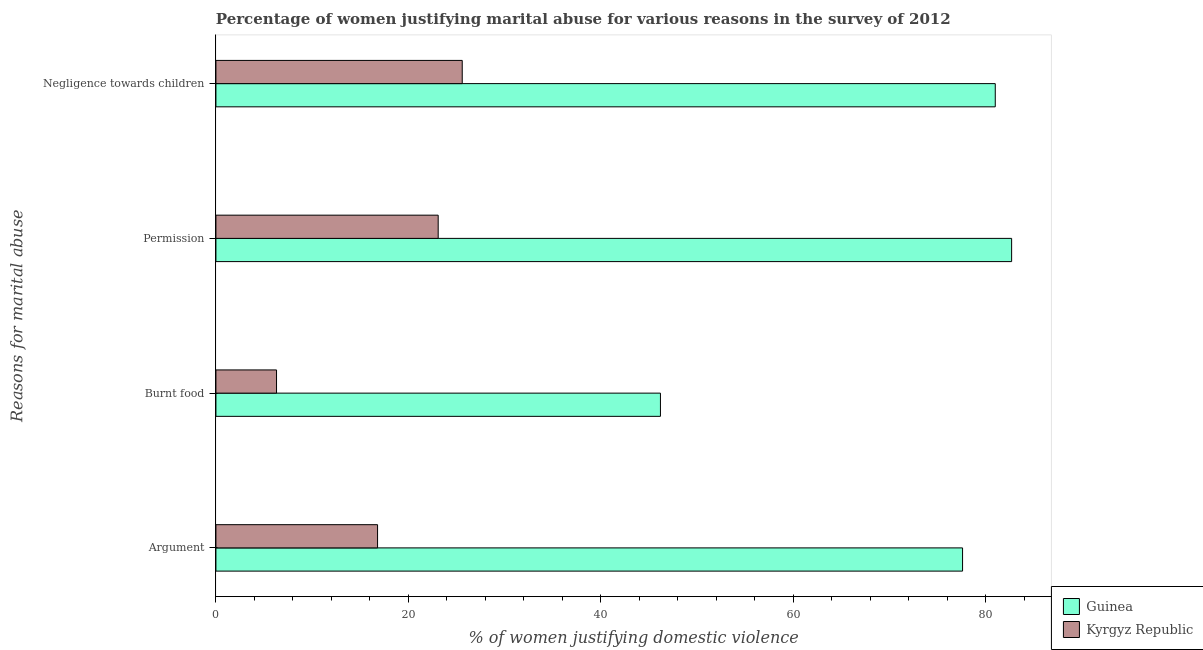Are the number of bars per tick equal to the number of legend labels?
Give a very brief answer. Yes. How many bars are there on the 1st tick from the top?
Ensure brevity in your answer.  2. What is the label of the 2nd group of bars from the top?
Offer a terse response. Permission. What is the percentage of women justifying abuse in the case of an argument in Kyrgyz Republic?
Your answer should be compact. 16.8. Across all countries, what is the maximum percentage of women justifying abuse for burning food?
Your answer should be compact. 46.2. In which country was the percentage of women justifying abuse in the case of an argument maximum?
Your answer should be very brief. Guinea. In which country was the percentage of women justifying abuse for showing negligence towards children minimum?
Offer a very short reply. Kyrgyz Republic. What is the total percentage of women justifying abuse for going without permission in the graph?
Give a very brief answer. 105.8. What is the difference between the percentage of women justifying abuse in the case of an argument in Kyrgyz Republic and that in Guinea?
Make the answer very short. -60.8. What is the difference between the percentage of women justifying abuse in the case of an argument in Kyrgyz Republic and the percentage of women justifying abuse for burning food in Guinea?
Ensure brevity in your answer.  -29.4. What is the average percentage of women justifying abuse in the case of an argument per country?
Provide a succinct answer. 47.2. What is the difference between the percentage of women justifying abuse in the case of an argument and percentage of women justifying abuse for going without permission in Guinea?
Your response must be concise. -5.1. What is the ratio of the percentage of women justifying abuse in the case of an argument in Kyrgyz Republic to that in Guinea?
Give a very brief answer. 0.22. Is the difference between the percentage of women justifying abuse in the case of an argument in Kyrgyz Republic and Guinea greater than the difference between the percentage of women justifying abuse for going without permission in Kyrgyz Republic and Guinea?
Make the answer very short. No. What is the difference between the highest and the second highest percentage of women justifying abuse for burning food?
Ensure brevity in your answer.  39.9. What is the difference between the highest and the lowest percentage of women justifying abuse for showing negligence towards children?
Ensure brevity in your answer.  55.4. In how many countries, is the percentage of women justifying abuse in the case of an argument greater than the average percentage of women justifying abuse in the case of an argument taken over all countries?
Keep it short and to the point. 1. What does the 2nd bar from the top in Burnt food represents?
Give a very brief answer. Guinea. What does the 1st bar from the bottom in Burnt food represents?
Your response must be concise. Guinea. Is it the case that in every country, the sum of the percentage of women justifying abuse in the case of an argument and percentage of women justifying abuse for burning food is greater than the percentage of women justifying abuse for going without permission?
Keep it short and to the point. No. How many bars are there?
Your response must be concise. 8. Are the values on the major ticks of X-axis written in scientific E-notation?
Offer a very short reply. No. Does the graph contain grids?
Provide a short and direct response. No. Where does the legend appear in the graph?
Ensure brevity in your answer.  Bottom right. What is the title of the graph?
Your answer should be compact. Percentage of women justifying marital abuse for various reasons in the survey of 2012. What is the label or title of the X-axis?
Ensure brevity in your answer.  % of women justifying domestic violence. What is the label or title of the Y-axis?
Your answer should be compact. Reasons for marital abuse. What is the % of women justifying domestic violence of Guinea in Argument?
Your response must be concise. 77.6. What is the % of women justifying domestic violence in Kyrgyz Republic in Argument?
Offer a terse response. 16.8. What is the % of women justifying domestic violence of Guinea in Burnt food?
Offer a very short reply. 46.2. What is the % of women justifying domestic violence in Kyrgyz Republic in Burnt food?
Your answer should be compact. 6.3. What is the % of women justifying domestic violence of Guinea in Permission?
Offer a very short reply. 82.7. What is the % of women justifying domestic violence in Kyrgyz Republic in Permission?
Your answer should be very brief. 23.1. What is the % of women justifying domestic violence in Guinea in Negligence towards children?
Your answer should be compact. 81. What is the % of women justifying domestic violence in Kyrgyz Republic in Negligence towards children?
Offer a terse response. 25.6. Across all Reasons for marital abuse, what is the maximum % of women justifying domestic violence in Guinea?
Provide a succinct answer. 82.7. Across all Reasons for marital abuse, what is the maximum % of women justifying domestic violence in Kyrgyz Republic?
Ensure brevity in your answer.  25.6. Across all Reasons for marital abuse, what is the minimum % of women justifying domestic violence of Guinea?
Ensure brevity in your answer.  46.2. What is the total % of women justifying domestic violence of Guinea in the graph?
Your response must be concise. 287.5. What is the total % of women justifying domestic violence of Kyrgyz Republic in the graph?
Keep it short and to the point. 71.8. What is the difference between the % of women justifying domestic violence of Guinea in Argument and that in Burnt food?
Provide a succinct answer. 31.4. What is the difference between the % of women justifying domestic violence of Kyrgyz Republic in Argument and that in Permission?
Provide a short and direct response. -6.3. What is the difference between the % of women justifying domestic violence in Guinea in Burnt food and that in Permission?
Make the answer very short. -36.5. What is the difference between the % of women justifying domestic violence in Kyrgyz Republic in Burnt food and that in Permission?
Offer a terse response. -16.8. What is the difference between the % of women justifying domestic violence in Guinea in Burnt food and that in Negligence towards children?
Offer a very short reply. -34.8. What is the difference between the % of women justifying domestic violence in Kyrgyz Republic in Burnt food and that in Negligence towards children?
Your response must be concise. -19.3. What is the difference between the % of women justifying domestic violence in Guinea in Permission and that in Negligence towards children?
Your response must be concise. 1.7. What is the difference between the % of women justifying domestic violence of Kyrgyz Republic in Permission and that in Negligence towards children?
Provide a short and direct response. -2.5. What is the difference between the % of women justifying domestic violence in Guinea in Argument and the % of women justifying domestic violence in Kyrgyz Republic in Burnt food?
Provide a short and direct response. 71.3. What is the difference between the % of women justifying domestic violence in Guinea in Argument and the % of women justifying domestic violence in Kyrgyz Republic in Permission?
Your response must be concise. 54.5. What is the difference between the % of women justifying domestic violence of Guinea in Argument and the % of women justifying domestic violence of Kyrgyz Republic in Negligence towards children?
Offer a very short reply. 52. What is the difference between the % of women justifying domestic violence of Guinea in Burnt food and the % of women justifying domestic violence of Kyrgyz Republic in Permission?
Keep it short and to the point. 23.1. What is the difference between the % of women justifying domestic violence of Guinea in Burnt food and the % of women justifying domestic violence of Kyrgyz Republic in Negligence towards children?
Offer a very short reply. 20.6. What is the difference between the % of women justifying domestic violence of Guinea in Permission and the % of women justifying domestic violence of Kyrgyz Republic in Negligence towards children?
Make the answer very short. 57.1. What is the average % of women justifying domestic violence in Guinea per Reasons for marital abuse?
Offer a very short reply. 71.88. What is the average % of women justifying domestic violence in Kyrgyz Republic per Reasons for marital abuse?
Your answer should be compact. 17.95. What is the difference between the % of women justifying domestic violence of Guinea and % of women justifying domestic violence of Kyrgyz Republic in Argument?
Ensure brevity in your answer.  60.8. What is the difference between the % of women justifying domestic violence of Guinea and % of women justifying domestic violence of Kyrgyz Republic in Burnt food?
Your answer should be very brief. 39.9. What is the difference between the % of women justifying domestic violence in Guinea and % of women justifying domestic violence in Kyrgyz Republic in Permission?
Offer a very short reply. 59.6. What is the difference between the % of women justifying domestic violence of Guinea and % of women justifying domestic violence of Kyrgyz Republic in Negligence towards children?
Provide a succinct answer. 55.4. What is the ratio of the % of women justifying domestic violence in Guinea in Argument to that in Burnt food?
Keep it short and to the point. 1.68. What is the ratio of the % of women justifying domestic violence in Kyrgyz Republic in Argument to that in Burnt food?
Make the answer very short. 2.67. What is the ratio of the % of women justifying domestic violence in Guinea in Argument to that in Permission?
Your answer should be compact. 0.94. What is the ratio of the % of women justifying domestic violence of Kyrgyz Republic in Argument to that in Permission?
Ensure brevity in your answer.  0.73. What is the ratio of the % of women justifying domestic violence of Guinea in Argument to that in Negligence towards children?
Offer a terse response. 0.96. What is the ratio of the % of women justifying domestic violence of Kyrgyz Republic in Argument to that in Negligence towards children?
Your answer should be very brief. 0.66. What is the ratio of the % of women justifying domestic violence of Guinea in Burnt food to that in Permission?
Your answer should be very brief. 0.56. What is the ratio of the % of women justifying domestic violence of Kyrgyz Republic in Burnt food to that in Permission?
Keep it short and to the point. 0.27. What is the ratio of the % of women justifying domestic violence in Guinea in Burnt food to that in Negligence towards children?
Your answer should be compact. 0.57. What is the ratio of the % of women justifying domestic violence of Kyrgyz Republic in Burnt food to that in Negligence towards children?
Your answer should be compact. 0.25. What is the ratio of the % of women justifying domestic violence in Guinea in Permission to that in Negligence towards children?
Make the answer very short. 1.02. What is the ratio of the % of women justifying domestic violence of Kyrgyz Republic in Permission to that in Negligence towards children?
Make the answer very short. 0.9. What is the difference between the highest and the lowest % of women justifying domestic violence in Guinea?
Provide a short and direct response. 36.5. What is the difference between the highest and the lowest % of women justifying domestic violence of Kyrgyz Republic?
Your answer should be compact. 19.3. 